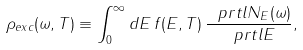Convert formula to latex. <formula><loc_0><loc_0><loc_500><loc_500>\rho _ { e x c } ( \omega , T ) \equiv \int _ { 0 } ^ { \infty } d E \, f ( E , T ) \, \frac { \ p r t l N _ { E } ( \omega ) } { \ p r t l E } ,</formula> 